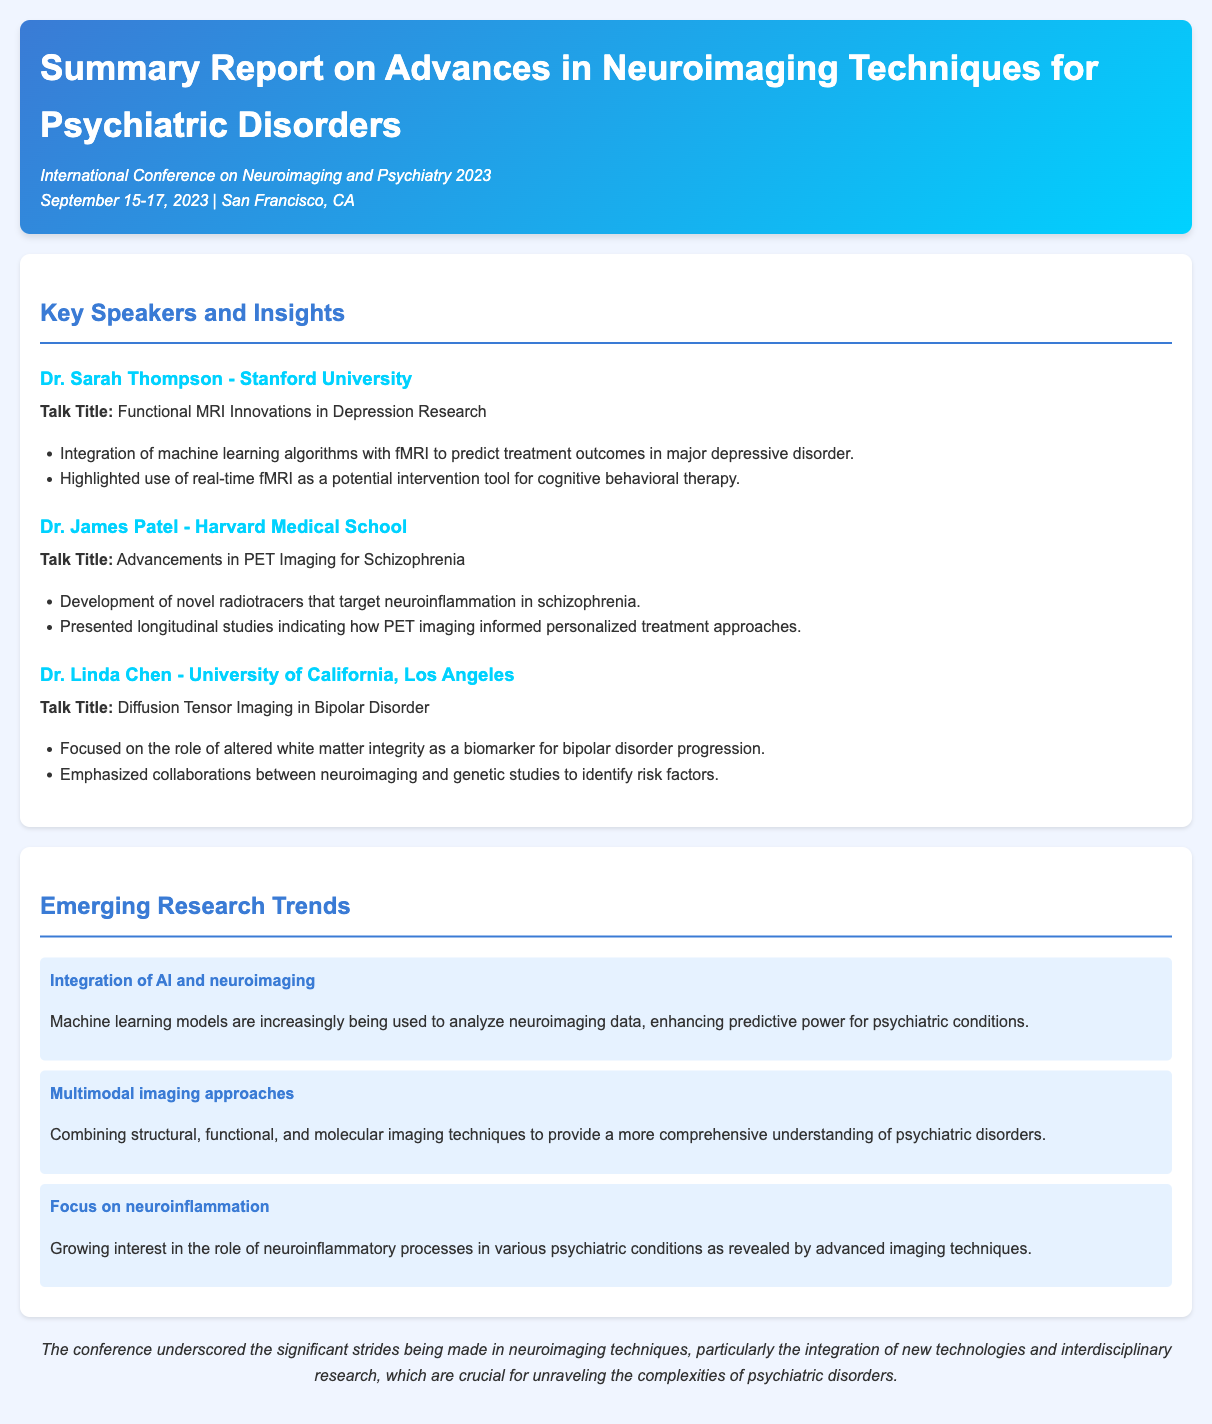What was the date of the conference? The date of the conference is mentioned as September 15-17, 2023.
Answer: September 15-17, 2023 Who delivered the talk on functional MRI innovations? The speaker who delivered this talk is Dr. Sarah Thompson from Stanford University.
Answer: Dr. Sarah Thompson What type of imaging is emphasized in Dr. Linda Chen's talk? Dr. Linda Chen's talk focuses on Diffusion Tensor Imaging in Bipolar Disorder.
Answer: Diffusion Tensor Imaging What is one of the emerging research trends discussed in the document? The document mentions several trends; one is the integration of AI and neuroimaging.
Answer: Integration of AI and neuroimaging How many key speakers are highlighted in the report? The report highlights three key speakers.
Answer: Three What university is associated with Dr. James Patel? Dr. James Patel is associated with Harvard Medical School.
Answer: Harvard Medical School What did Dr. Linda Chen emphasize regarding risk factors? Dr. Linda Chen emphasized collaborations between neuroimaging and genetic studies to identify risk factors.
Answer: Collaborations between neuroimaging and genetic studies What was discussed as a key feature of PET imaging in Dr. James Patel's presentation? A key feature discussed is the development of novel radiotracers that target neuroinflammation in schizophrenia.
Answer: Novel radiotracers that target neuroinflammation What conclusion does the conference report highlight? The conclusion highlights significant strides in neuroimaging techniques and interdisciplinary research.
Answer: Significant strides in neuroimaging techniques and interdisciplinary research 